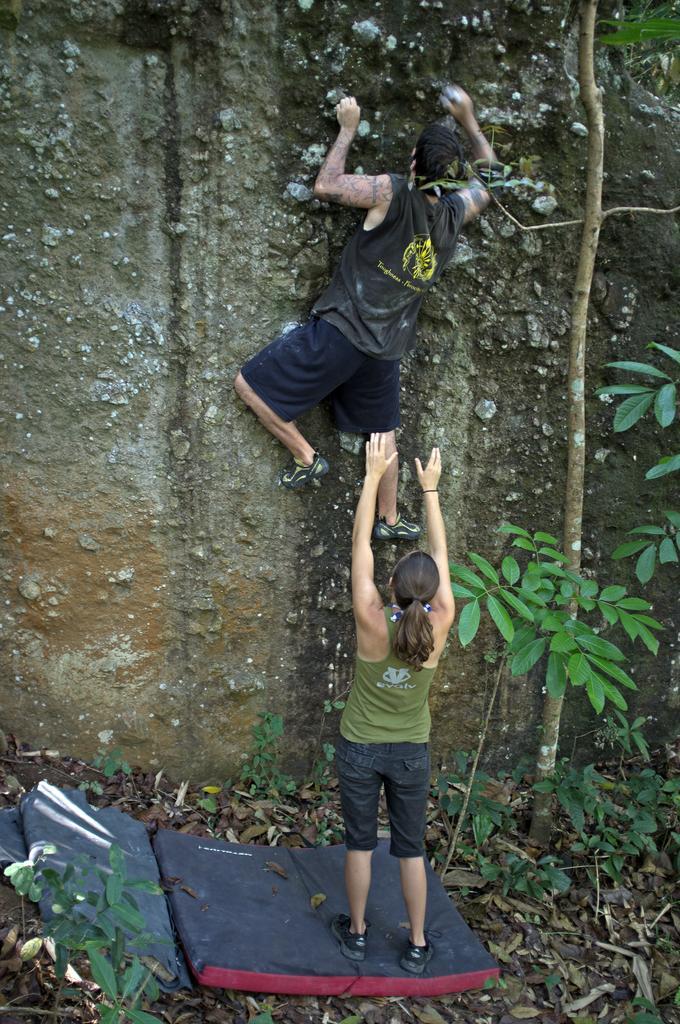How would you summarize this image in a sentence or two? As we can see in the image, there are two persons. The women is standing on mat and the man is climbing the wall and there is a tree stem here. 